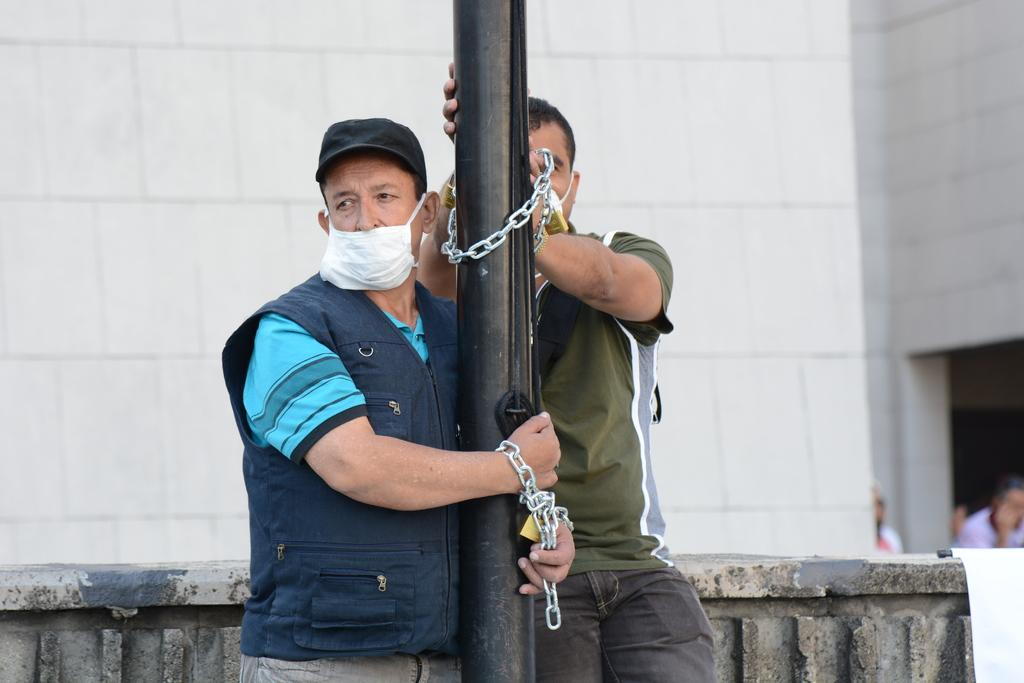How many people are in the foreground of the image? There are two persons in the foreground. What connects the two persons in the foreground? The two persons are connected by a metal chain. What is present in the foreground besides the two persons? There is a pole in the foreground. What can be seen in the background of the image? There is a fence, a building, a door, and three persons in the background. Can you describe the time of day when the image might have been taken? The image might have been taken during the day, as there is no indication of darkness or artificial lighting. What type of slope can be seen in the image? There is no slope present in the image. What event are the two persons in the foreground participating in? The image does not provide enough information to determine what event, if any, the two persons are participating in. 